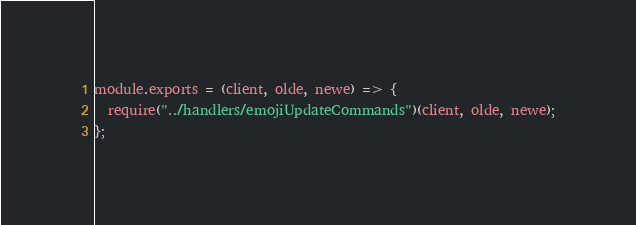<code> <loc_0><loc_0><loc_500><loc_500><_JavaScript_>module.exports = (client, olde, newe) => {
  require("../handlers/emojiUpdateCommands")(client, olde, newe);
};
</code> 